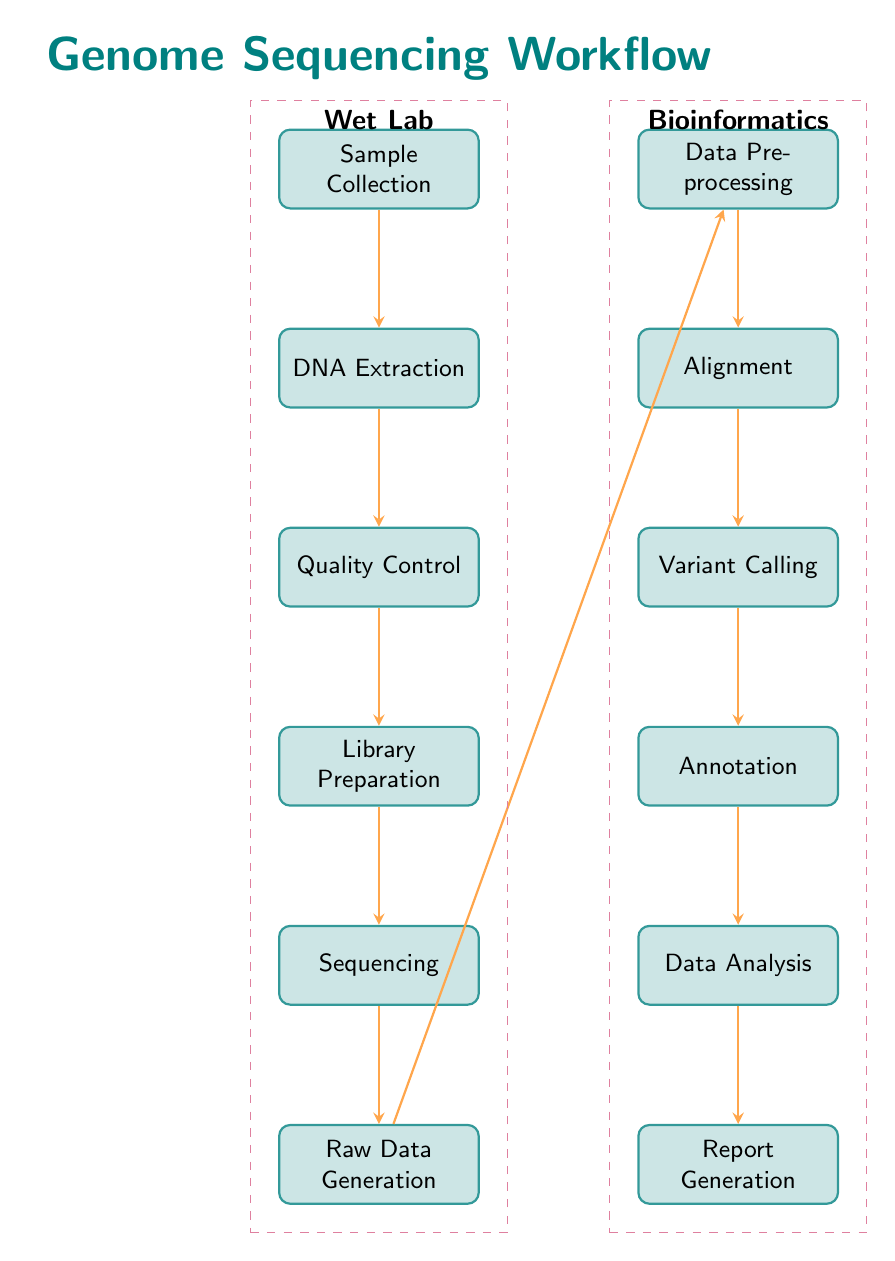What is the starting point of the genome sequencing workflow? The diagram indicates that the starting point of the genome sequencing workflow is "Sample Collection." It is the topmost node in the flowchart, from which the entire process begins.
Answer: Sample Collection How many steps are there in the wet lab process? The wet lab process includes six steps, which are listed as nodes in the diagram: Sample Collection, DNA Extraction, Quality Control, Library Preparation, Sequencing, and Raw Data Generation.
Answer: Six What is the first bioinformatics step following raw data generation? After "Raw Data Generation," the first step in the bioinformatics process is "Data Preprocessing." This follows directly from the node and indicates the next phase of the workflow.
Answer: Data Preprocessing What type of process is "Quality Control"? "Quality Control" is designated as a process within the diagram, which is visually indicated through a rectangular shape. The arrows show it as a necessary step in the sequence of the wet lab workflow.
Answer: Process How many nodes are in the entire diagram? The entire diagram contains twelve nodes. Six nodes are related to the wet lab process and six nodes to the bioinformatics process, totaling twelve.
Answer: Twelve What is the final step in the data analysis phase? The last step in the data analysis phase is "Report Generation." This is the bottom-most node in the bioinformatics sequence, indicating the completion of the workflow.
Answer: Report Generation What aspect of the workflow does the dashed purple box around certain nodes signify? The dashed purple box represents the "Wet Lab" aspect of the workflow, enclosing the first six nodes, which are all related to laboratory procedures involved in genome sequencing.
Answer: Wet Lab Which two nodes are directly connected by the arrow from Library Preparation? The arrow originating from "Library Preparation" connects directly to "Sequencing," indicating the order of steps in the genome sequencing process.
Answer: Sequencing What is the last step after variant calling in the bioinformatics process? Following "Variant Calling," the next step in the bioinformatics process is "Annotation," which is the immediate subsequent node indicating a progression in data analysis.
Answer: Annotation 